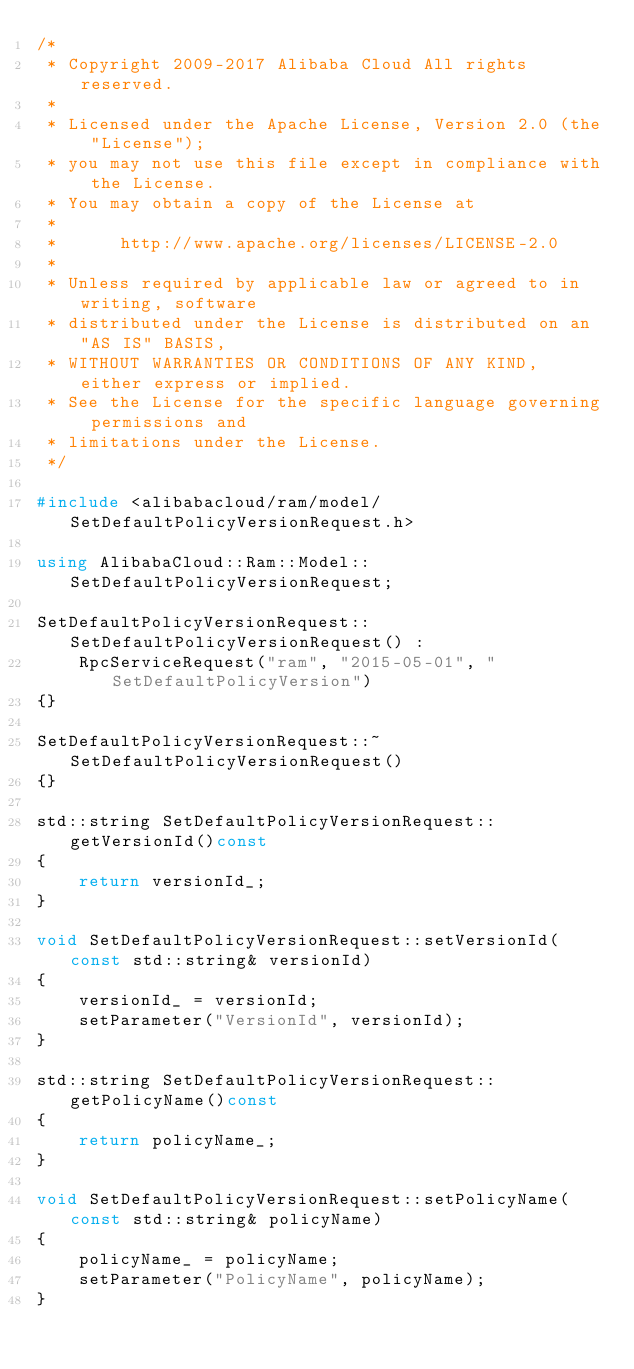Convert code to text. <code><loc_0><loc_0><loc_500><loc_500><_C++_>/*
 * Copyright 2009-2017 Alibaba Cloud All rights reserved.
 * 
 * Licensed under the Apache License, Version 2.0 (the "License");
 * you may not use this file except in compliance with the License.
 * You may obtain a copy of the License at
 * 
 *      http://www.apache.org/licenses/LICENSE-2.0
 * 
 * Unless required by applicable law or agreed to in writing, software
 * distributed under the License is distributed on an "AS IS" BASIS,
 * WITHOUT WARRANTIES OR CONDITIONS OF ANY KIND, either express or implied.
 * See the License for the specific language governing permissions and
 * limitations under the License.
 */

#include <alibabacloud/ram/model/SetDefaultPolicyVersionRequest.h>

using AlibabaCloud::Ram::Model::SetDefaultPolicyVersionRequest;

SetDefaultPolicyVersionRequest::SetDefaultPolicyVersionRequest() :
	RpcServiceRequest("ram", "2015-05-01", "SetDefaultPolicyVersion")
{}

SetDefaultPolicyVersionRequest::~SetDefaultPolicyVersionRequest()
{}

std::string SetDefaultPolicyVersionRequest::getVersionId()const
{
	return versionId_;
}

void SetDefaultPolicyVersionRequest::setVersionId(const std::string& versionId)
{
	versionId_ = versionId;
	setParameter("VersionId", versionId);
}

std::string SetDefaultPolicyVersionRequest::getPolicyName()const
{
	return policyName_;
}

void SetDefaultPolicyVersionRequest::setPolicyName(const std::string& policyName)
{
	policyName_ = policyName;
	setParameter("PolicyName", policyName);
}

</code> 